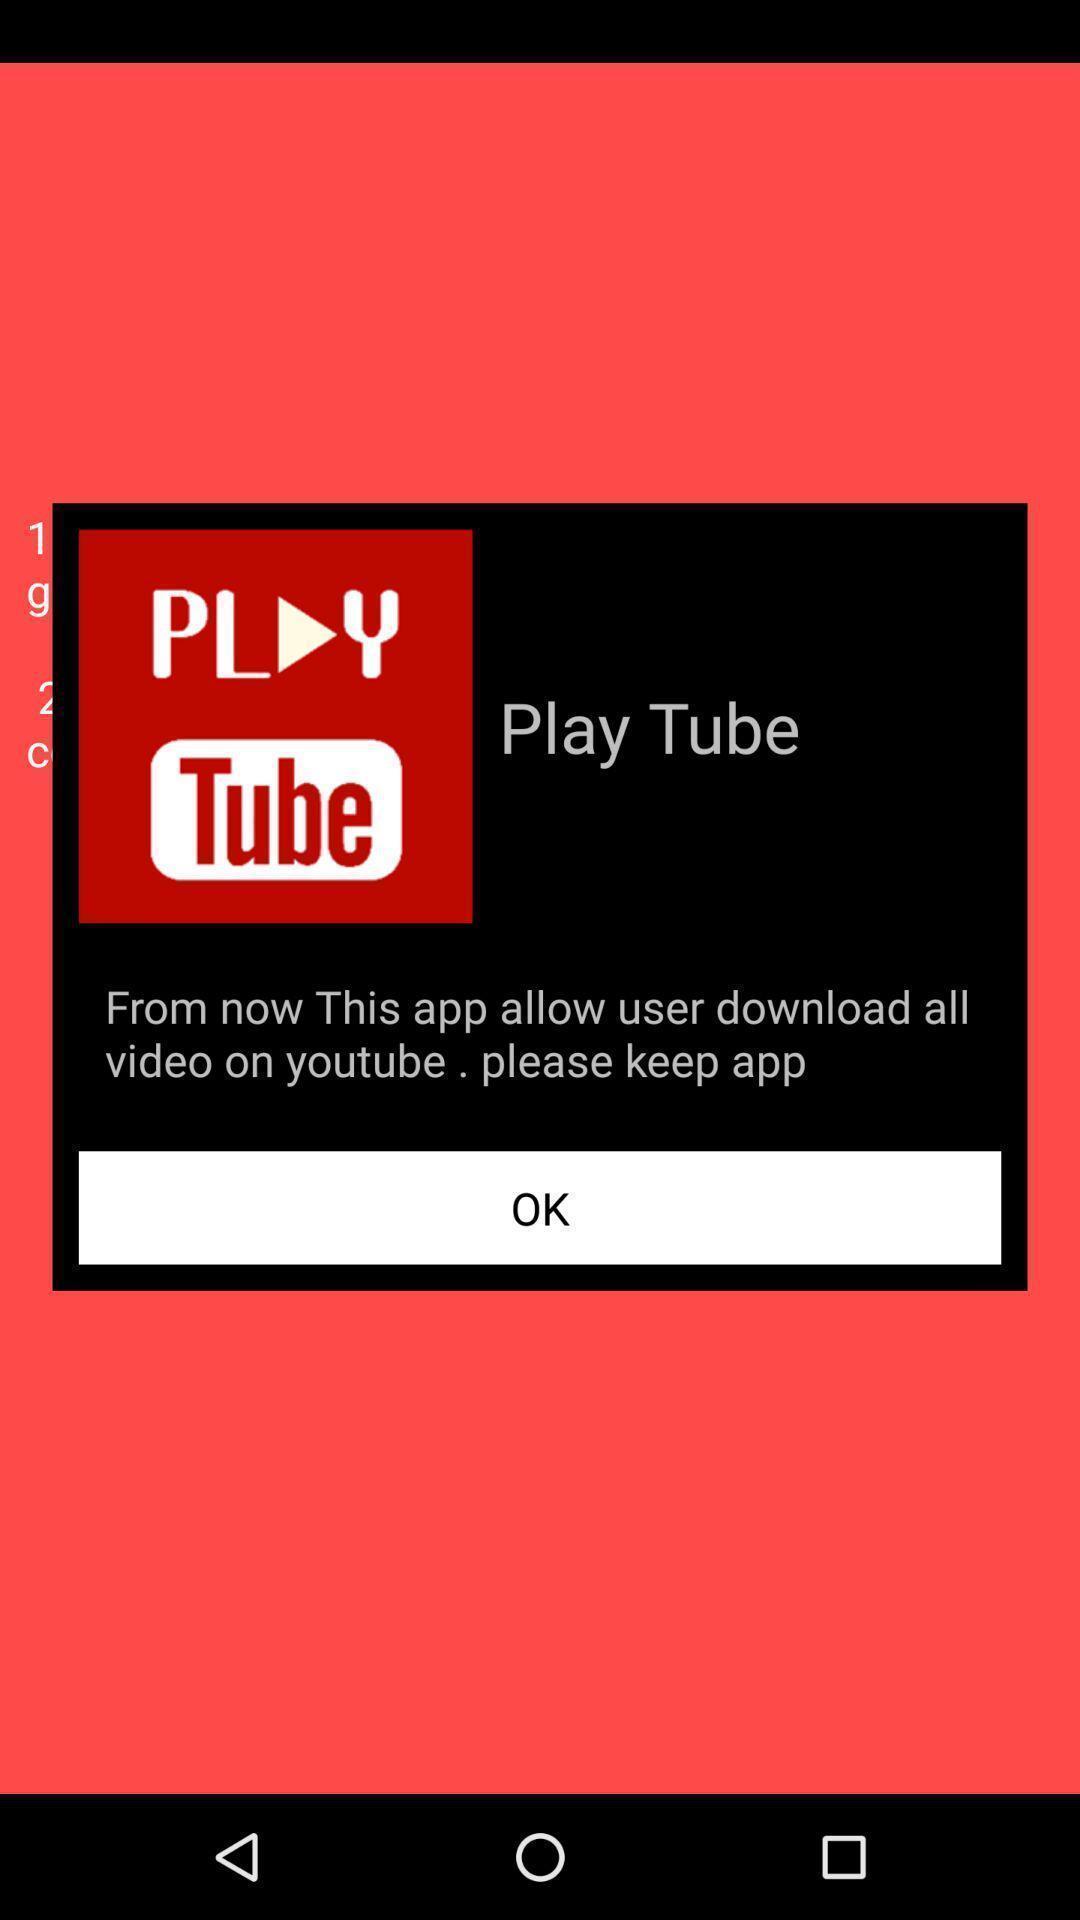What details can you identify in this image? Pop-up displaying a message of a video sharing app. 